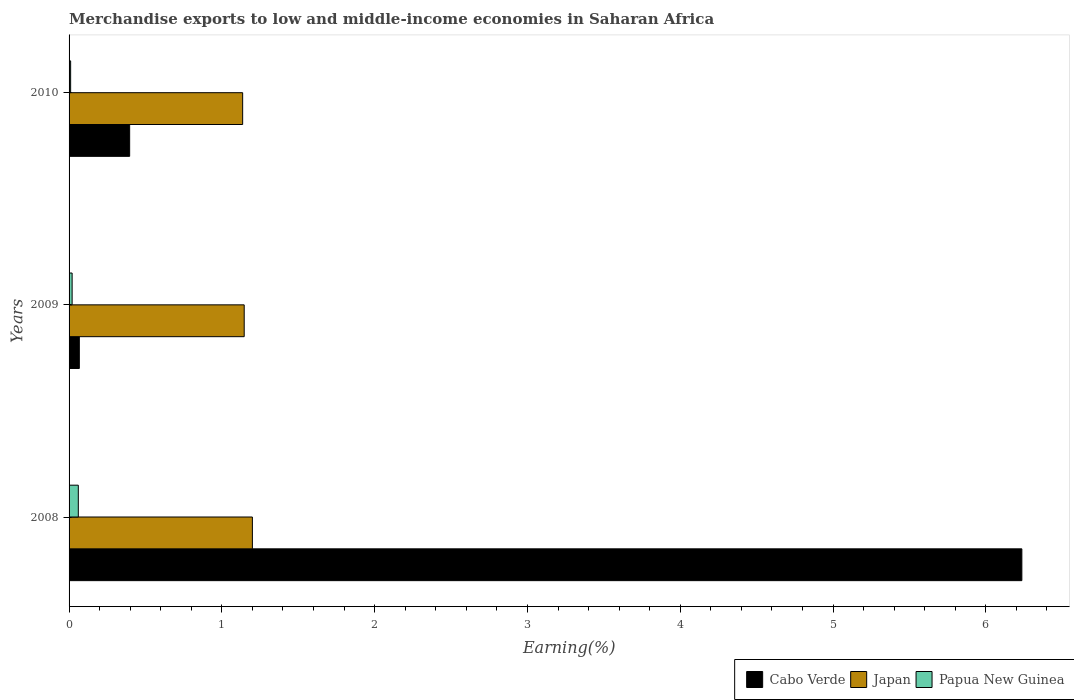How many different coloured bars are there?
Provide a succinct answer. 3. Are the number of bars per tick equal to the number of legend labels?
Give a very brief answer. Yes. In how many cases, is the number of bars for a given year not equal to the number of legend labels?
Provide a succinct answer. 0. What is the percentage of amount earned from merchandise exports in Cabo Verde in 2008?
Provide a short and direct response. 6.24. Across all years, what is the maximum percentage of amount earned from merchandise exports in Cabo Verde?
Give a very brief answer. 6.24. Across all years, what is the minimum percentage of amount earned from merchandise exports in Japan?
Provide a succinct answer. 1.14. In which year was the percentage of amount earned from merchandise exports in Papua New Guinea maximum?
Your answer should be compact. 2008. In which year was the percentage of amount earned from merchandise exports in Papua New Guinea minimum?
Provide a succinct answer. 2010. What is the total percentage of amount earned from merchandise exports in Papua New Guinea in the graph?
Provide a short and direct response. 0.09. What is the difference between the percentage of amount earned from merchandise exports in Japan in 2008 and that in 2009?
Offer a terse response. 0.05. What is the difference between the percentage of amount earned from merchandise exports in Japan in 2010 and the percentage of amount earned from merchandise exports in Cabo Verde in 2008?
Give a very brief answer. -5.1. What is the average percentage of amount earned from merchandise exports in Japan per year?
Give a very brief answer. 1.16. In the year 2008, what is the difference between the percentage of amount earned from merchandise exports in Japan and percentage of amount earned from merchandise exports in Papua New Guinea?
Your response must be concise. 1.14. In how many years, is the percentage of amount earned from merchandise exports in Cabo Verde greater than 3 %?
Provide a succinct answer. 1. What is the ratio of the percentage of amount earned from merchandise exports in Japan in 2008 to that in 2010?
Provide a succinct answer. 1.06. Is the percentage of amount earned from merchandise exports in Cabo Verde in 2008 less than that in 2010?
Offer a very short reply. No. What is the difference between the highest and the second highest percentage of amount earned from merchandise exports in Cabo Verde?
Your answer should be very brief. 5.84. What is the difference between the highest and the lowest percentage of amount earned from merchandise exports in Papua New Guinea?
Offer a very short reply. 0.05. What does the 3rd bar from the bottom in 2009 represents?
Your response must be concise. Papua New Guinea. Is it the case that in every year, the sum of the percentage of amount earned from merchandise exports in Japan and percentage of amount earned from merchandise exports in Cabo Verde is greater than the percentage of amount earned from merchandise exports in Papua New Guinea?
Ensure brevity in your answer.  Yes. Are the values on the major ticks of X-axis written in scientific E-notation?
Your response must be concise. No. Does the graph contain any zero values?
Ensure brevity in your answer.  No. Where does the legend appear in the graph?
Offer a terse response. Bottom right. What is the title of the graph?
Give a very brief answer. Merchandise exports to low and middle-income economies in Saharan Africa. What is the label or title of the X-axis?
Give a very brief answer. Earning(%). What is the label or title of the Y-axis?
Your answer should be very brief. Years. What is the Earning(%) in Cabo Verde in 2008?
Make the answer very short. 6.24. What is the Earning(%) in Japan in 2008?
Give a very brief answer. 1.2. What is the Earning(%) of Papua New Guinea in 2008?
Give a very brief answer. 0.06. What is the Earning(%) in Cabo Verde in 2009?
Offer a very short reply. 0.07. What is the Earning(%) in Japan in 2009?
Your answer should be very brief. 1.15. What is the Earning(%) of Papua New Guinea in 2009?
Ensure brevity in your answer.  0.02. What is the Earning(%) in Cabo Verde in 2010?
Offer a terse response. 0.4. What is the Earning(%) in Japan in 2010?
Provide a short and direct response. 1.14. What is the Earning(%) of Papua New Guinea in 2010?
Keep it short and to the point. 0.01. Across all years, what is the maximum Earning(%) in Cabo Verde?
Your response must be concise. 6.24. Across all years, what is the maximum Earning(%) of Japan?
Provide a succinct answer. 1.2. Across all years, what is the maximum Earning(%) of Papua New Guinea?
Your answer should be very brief. 0.06. Across all years, what is the minimum Earning(%) of Cabo Verde?
Ensure brevity in your answer.  0.07. Across all years, what is the minimum Earning(%) of Japan?
Keep it short and to the point. 1.14. Across all years, what is the minimum Earning(%) in Papua New Guinea?
Your response must be concise. 0.01. What is the total Earning(%) of Cabo Verde in the graph?
Offer a terse response. 6.7. What is the total Earning(%) in Japan in the graph?
Keep it short and to the point. 3.48. What is the total Earning(%) of Papua New Guinea in the graph?
Keep it short and to the point. 0.09. What is the difference between the Earning(%) in Cabo Verde in 2008 and that in 2009?
Make the answer very short. 6.17. What is the difference between the Earning(%) of Japan in 2008 and that in 2009?
Your answer should be compact. 0.05. What is the difference between the Earning(%) of Papua New Guinea in 2008 and that in 2009?
Ensure brevity in your answer.  0.04. What is the difference between the Earning(%) of Cabo Verde in 2008 and that in 2010?
Give a very brief answer. 5.84. What is the difference between the Earning(%) in Japan in 2008 and that in 2010?
Provide a short and direct response. 0.06. What is the difference between the Earning(%) of Papua New Guinea in 2008 and that in 2010?
Your answer should be compact. 0.05. What is the difference between the Earning(%) in Cabo Verde in 2009 and that in 2010?
Provide a short and direct response. -0.33. What is the difference between the Earning(%) in Japan in 2009 and that in 2010?
Keep it short and to the point. 0.01. What is the difference between the Earning(%) of Papua New Guinea in 2009 and that in 2010?
Provide a short and direct response. 0.01. What is the difference between the Earning(%) in Cabo Verde in 2008 and the Earning(%) in Japan in 2009?
Give a very brief answer. 5.09. What is the difference between the Earning(%) of Cabo Verde in 2008 and the Earning(%) of Papua New Guinea in 2009?
Keep it short and to the point. 6.22. What is the difference between the Earning(%) of Japan in 2008 and the Earning(%) of Papua New Guinea in 2009?
Offer a terse response. 1.18. What is the difference between the Earning(%) of Cabo Verde in 2008 and the Earning(%) of Japan in 2010?
Ensure brevity in your answer.  5.1. What is the difference between the Earning(%) of Cabo Verde in 2008 and the Earning(%) of Papua New Guinea in 2010?
Give a very brief answer. 6.23. What is the difference between the Earning(%) of Japan in 2008 and the Earning(%) of Papua New Guinea in 2010?
Your response must be concise. 1.19. What is the difference between the Earning(%) of Cabo Verde in 2009 and the Earning(%) of Japan in 2010?
Make the answer very short. -1.07. What is the difference between the Earning(%) of Cabo Verde in 2009 and the Earning(%) of Papua New Guinea in 2010?
Your answer should be very brief. 0.06. What is the difference between the Earning(%) in Japan in 2009 and the Earning(%) in Papua New Guinea in 2010?
Your answer should be very brief. 1.14. What is the average Earning(%) of Cabo Verde per year?
Keep it short and to the point. 2.23. What is the average Earning(%) of Japan per year?
Make the answer very short. 1.16. What is the average Earning(%) of Papua New Guinea per year?
Provide a short and direct response. 0.03. In the year 2008, what is the difference between the Earning(%) in Cabo Verde and Earning(%) in Japan?
Offer a very short reply. 5.04. In the year 2008, what is the difference between the Earning(%) of Cabo Verde and Earning(%) of Papua New Guinea?
Your answer should be very brief. 6.18. In the year 2008, what is the difference between the Earning(%) of Japan and Earning(%) of Papua New Guinea?
Offer a very short reply. 1.14. In the year 2009, what is the difference between the Earning(%) of Cabo Verde and Earning(%) of Japan?
Your answer should be compact. -1.08. In the year 2009, what is the difference between the Earning(%) in Cabo Verde and Earning(%) in Papua New Guinea?
Your response must be concise. 0.05. In the year 2009, what is the difference between the Earning(%) of Japan and Earning(%) of Papua New Guinea?
Keep it short and to the point. 1.13. In the year 2010, what is the difference between the Earning(%) in Cabo Verde and Earning(%) in Japan?
Make the answer very short. -0.74. In the year 2010, what is the difference between the Earning(%) of Cabo Verde and Earning(%) of Papua New Guinea?
Provide a succinct answer. 0.39. In the year 2010, what is the difference between the Earning(%) of Japan and Earning(%) of Papua New Guinea?
Your answer should be very brief. 1.13. What is the ratio of the Earning(%) of Cabo Verde in 2008 to that in 2009?
Your answer should be very brief. 92.89. What is the ratio of the Earning(%) in Japan in 2008 to that in 2009?
Your answer should be compact. 1.05. What is the ratio of the Earning(%) in Papua New Guinea in 2008 to that in 2009?
Your answer should be compact. 3.03. What is the ratio of the Earning(%) in Cabo Verde in 2008 to that in 2010?
Your answer should be very brief. 15.73. What is the ratio of the Earning(%) in Japan in 2008 to that in 2010?
Provide a short and direct response. 1.06. What is the ratio of the Earning(%) in Papua New Guinea in 2008 to that in 2010?
Ensure brevity in your answer.  5.86. What is the ratio of the Earning(%) in Cabo Verde in 2009 to that in 2010?
Provide a short and direct response. 0.17. What is the ratio of the Earning(%) in Japan in 2009 to that in 2010?
Keep it short and to the point. 1.01. What is the ratio of the Earning(%) of Papua New Guinea in 2009 to that in 2010?
Your response must be concise. 1.94. What is the difference between the highest and the second highest Earning(%) of Cabo Verde?
Make the answer very short. 5.84. What is the difference between the highest and the second highest Earning(%) in Japan?
Make the answer very short. 0.05. What is the difference between the highest and the second highest Earning(%) of Papua New Guinea?
Your answer should be very brief. 0.04. What is the difference between the highest and the lowest Earning(%) of Cabo Verde?
Give a very brief answer. 6.17. What is the difference between the highest and the lowest Earning(%) in Japan?
Your answer should be compact. 0.06. What is the difference between the highest and the lowest Earning(%) of Papua New Guinea?
Give a very brief answer. 0.05. 